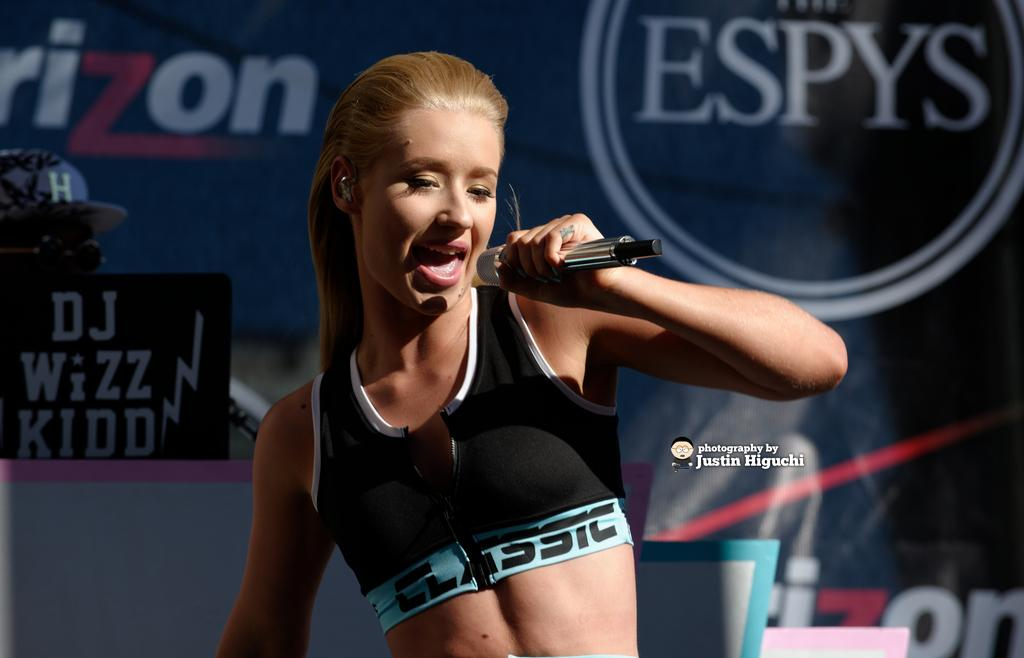Who is the main subject in the image? There is a woman in the image. What is the woman holding in the image? The woman is holding a microphone. What is the woman doing with the microphone? The woman is singing a song. What can be seen beside the woman in the image? There is a flexi beside the woman. What is written on the flexi? The flexi has the word "ESPYS" on it. What type of decision is the woman making in the image? There is no indication in the image that the woman is making a decision. She is singing with a microphone. 